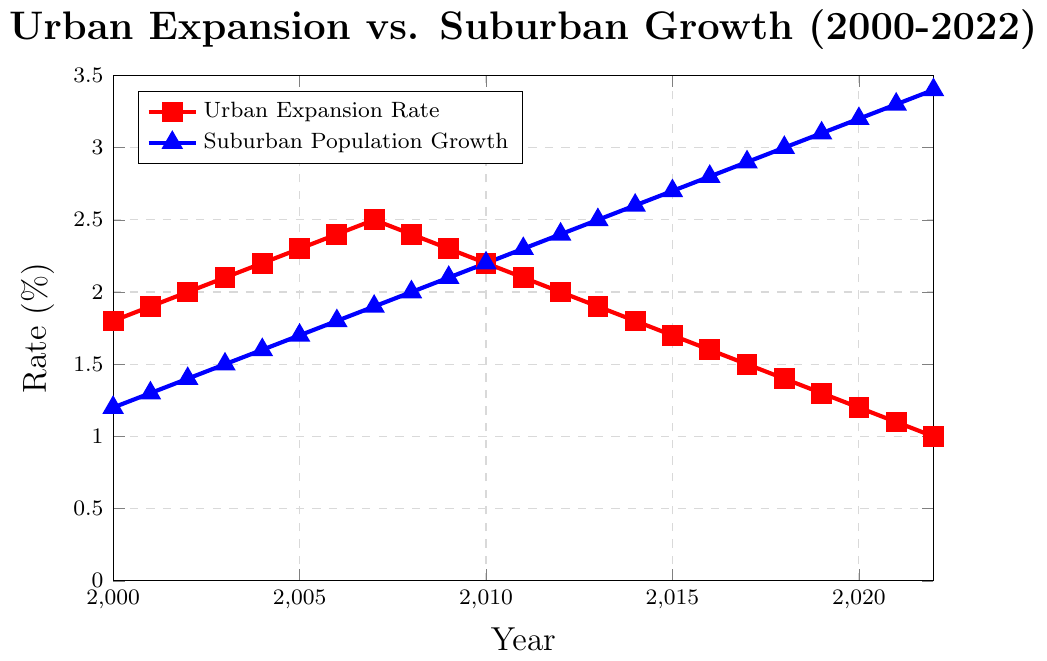What trend can you observe in the urban expansion rate from 2000 to 2022? The urban expansion rate shows a decreasing trend over the years. It starts at 1.8% in 2000 and consistently decreases to 1.0% by 2022.
Answer: Decreasing trend How does the suburban population growth rate in 2022 compare to the urban expansion rate in the same year? In 2022, the suburban population growth rate is 3.4%, while the urban expansion rate is 1.0%. This indicates that the suburban population growth is significantly higher than the urban expansion rate.
Answer: Suburban growth is higher By how much did the suburban population growth rate increase from 2000 to 2022? The suburban population growth rate was 1.2% in 2000 and increased to 3.4% in 2022. The increase is calculated as 3.4% - 1.2% = 2.2%.
Answer: 2.2% In which year was the suburban population growth rate equal to the urban expansion rate? By examining the chart, there is no year where the suburban population growth rate equals the urban expansion rate. The suburban population growth rate is always higher than the urban expansion rate after 2000.
Answer: Never What is the average urban expansion rate from 2000 to 2022? Sum all the yearly urban expansion rates and divide by the number of years: (1.8 + 1.9 + 2.0 + 2.1 + 2.2 + 2.3 + 2.4 + 2.5 + 2.4 + 2.3 + 2.2 + 2.1 + 2.0 + 1.9 + 1.8 + 1.7 + 1.6 + 1.5 + 1.4 + 1.3 + 1.2 + 1.1 + 1.0) / 23 = 1.85%
Answer: 1.85% What visual elements distinguish the urban expansion rate from the suburban population growth rate in the plot? The urban expansion rate is represented by a red line with square markers, while the suburban population growth rate is represented by a blue line with triangle markers.
Answer: Red line with squares vs. blue line with triangles Which year exhibits the largest gap between the urban expansion rate and the suburban population growth rate? The largest gap occurs in 2022: suburban growth rate (3.4%) - urban expansion rate (1.0%) = 2.4%.
Answer: 2022 Describe the overall relationship between urban expansion rate and suburban population growth rate over the years. From 2000 to 2022, the urban expansion rate generally decreases, while the suburban population growth rate consistently increases, indicating an inverse relationship between the two rates.
Answer: Inverse relationship What is the difference between the urban expansion rate and the suburban population growth rate in 2010? In 2010, the urban expansion rate is 2.2% and the suburban population growth rate is 2.2%. The difference is 2.2% - 2.2% = 0.0%.
Answer: 0.0% What can you infer about urban expansion and suburban population preferences from the visual trends? The decreasing urban expansion rate along with the increasing suburban population growth rate suggests that more people are choosing to live in suburban areas, leading to slower urban expansion.
Answer: Preference for suburban living 